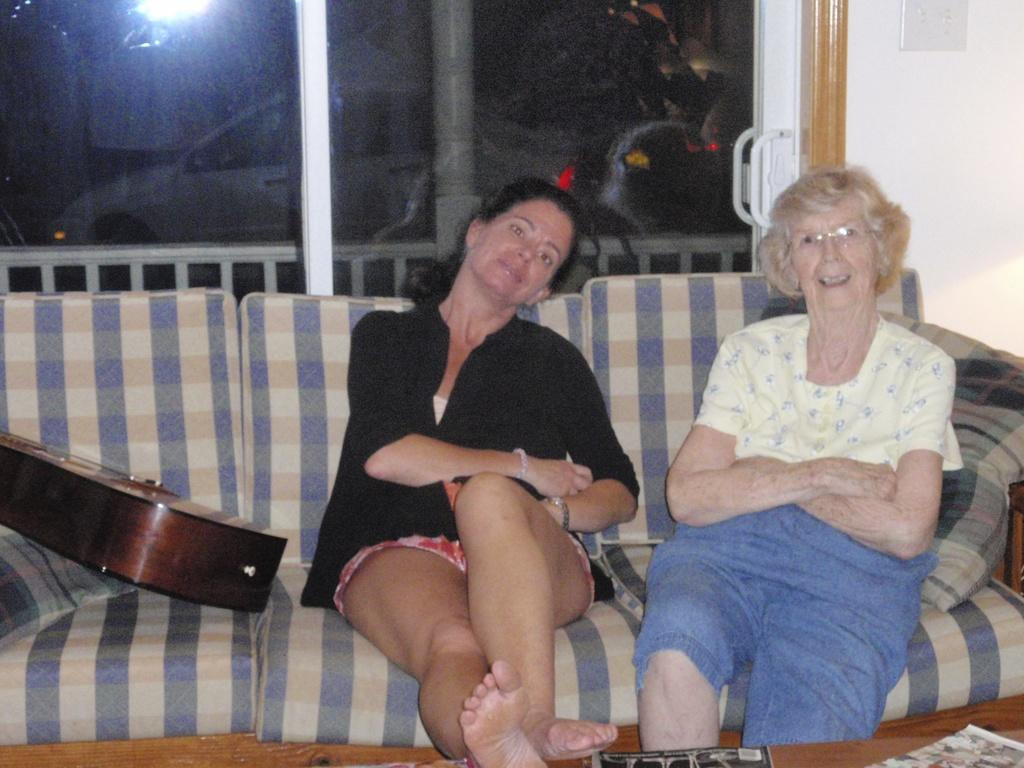How many women are in the image? There are two women in the image. What are the women doing in the image? The women are sitting on a sofa. What objects can be seen in the left corner of the image? There is a guitar and a pillow in the left corner of the image. What type of architectural feature is visible in the background of the image? There is a glass door in the background of the image. What type of pancake is being tested by the women in the image? There is no pancake present in the image, and the women are not testing anything. How many additional women are present in the image, making a total of five? There are only two women present in the image, not five. 